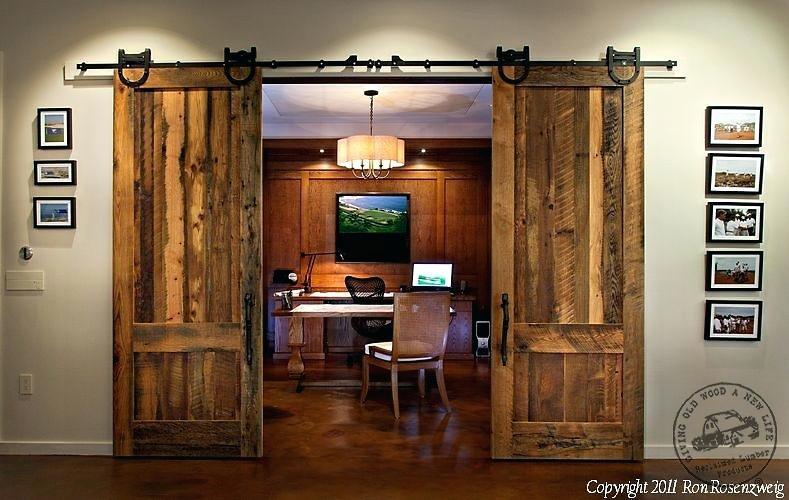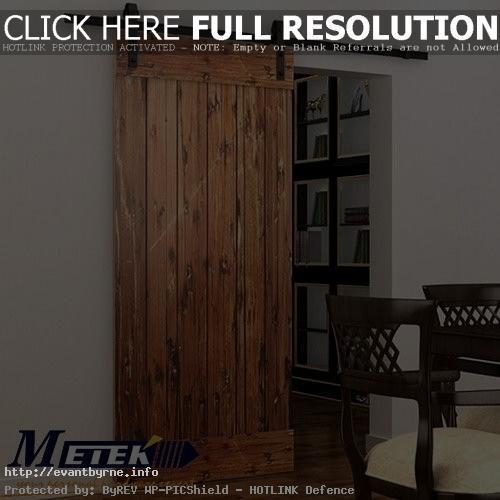The first image is the image on the left, the second image is the image on the right. Examine the images to the left and right. Is the description "The left and right image contains a total of three brown wooden hanging doors." accurate? Answer yes or no. Yes. The first image is the image on the left, the second image is the image on the right. Analyze the images presented: Is the assertion "The left image features a wide-open sliding 'barn style' wooden double door with a black bar at the top, and the right image shows a single barn-style wood plank door." valid? Answer yes or no. Yes. The first image is the image on the left, the second image is the image on the right. Assess this claim about the two images: "The left image features a 'barn style' wood-paneled double door with a black bar at the top, and the right image shows a single barn-style wood plank door.". Correct or not? Answer yes or no. Yes. The first image is the image on the left, the second image is the image on the right. Evaluate the accuracy of this statement regarding the images: "The left and right image contains a total of three brown wooden hanging doors.". Is it true? Answer yes or no. Yes. 